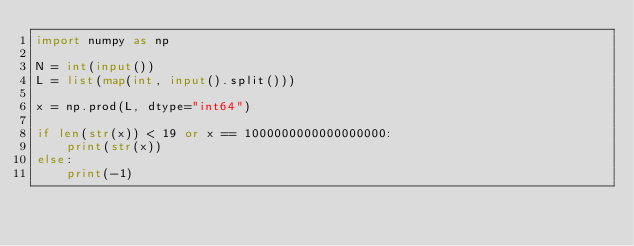<code> <loc_0><loc_0><loc_500><loc_500><_Python_>import numpy as np

N = int(input())
L = list(map(int, input().split()))

x = np.prod(L, dtype="int64")

if len(str(x)) < 19 or x == 1000000000000000000:
    print(str(x))
else:
    print(-1)
</code> 